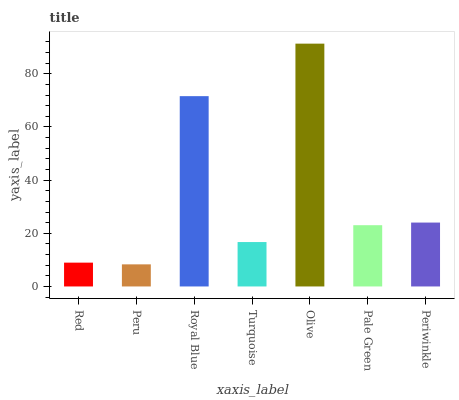Is Peru the minimum?
Answer yes or no. Yes. Is Olive the maximum?
Answer yes or no. Yes. Is Royal Blue the minimum?
Answer yes or no. No. Is Royal Blue the maximum?
Answer yes or no. No. Is Royal Blue greater than Peru?
Answer yes or no. Yes. Is Peru less than Royal Blue?
Answer yes or no. Yes. Is Peru greater than Royal Blue?
Answer yes or no. No. Is Royal Blue less than Peru?
Answer yes or no. No. Is Pale Green the high median?
Answer yes or no. Yes. Is Pale Green the low median?
Answer yes or no. Yes. Is Periwinkle the high median?
Answer yes or no. No. Is Periwinkle the low median?
Answer yes or no. No. 